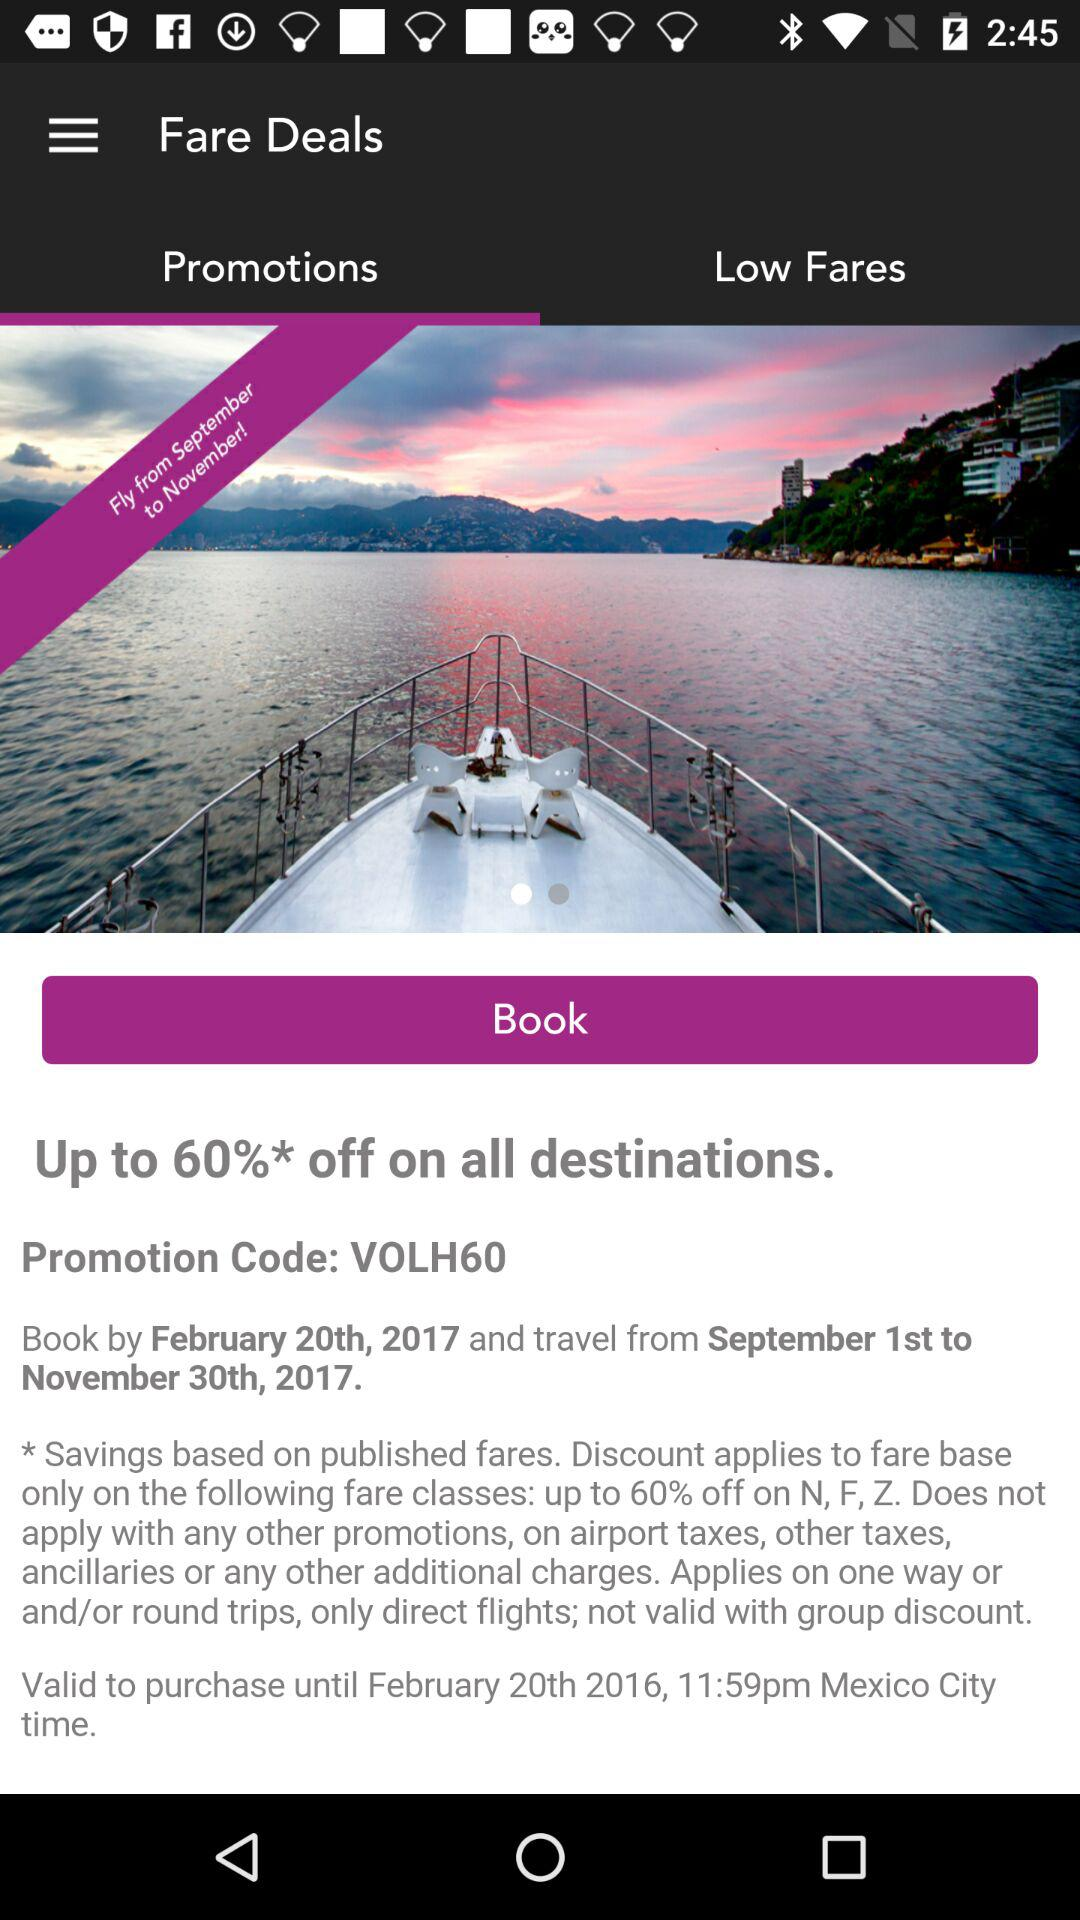What is the maximum discount offered?
Answer the question using a single word or phrase. 60% 